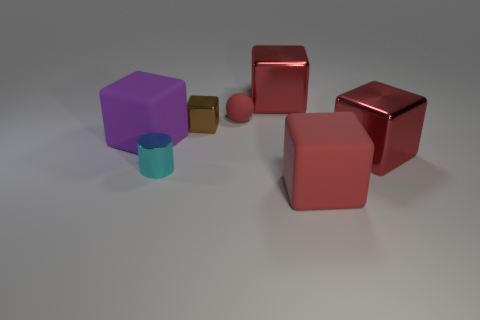Subtract all brown blocks. How many blocks are left? 4 Add 2 big blue metal blocks. How many objects exist? 9 Subtract all brown cubes. How many cubes are left? 4 Subtract all balls. How many objects are left? 6 Add 4 tiny red matte things. How many tiny red matte things are left? 5 Add 7 tiny brown metal things. How many tiny brown metal things exist? 8 Subtract 0 yellow cylinders. How many objects are left? 7 Subtract 3 cubes. How many cubes are left? 2 Subtract all purple blocks. Subtract all red balls. How many blocks are left? 4 Subtract all yellow cubes. How many blue cylinders are left? 0 